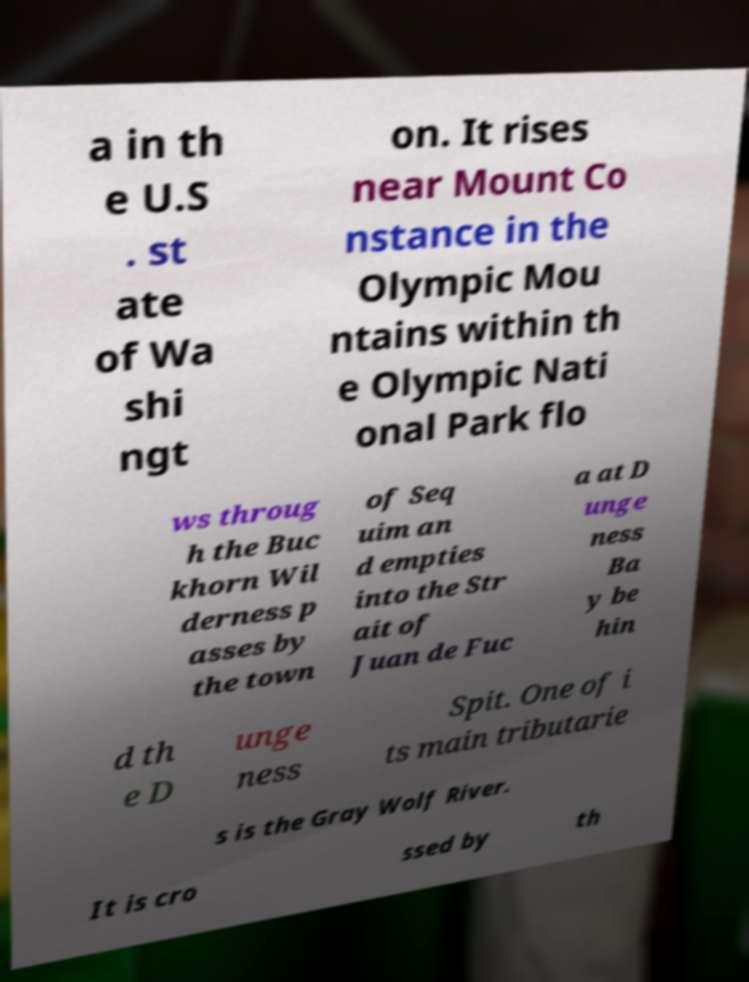Please identify and transcribe the text found in this image. a in th e U.S . st ate of Wa shi ngt on. It rises near Mount Co nstance in the Olympic Mou ntains within th e Olympic Nati onal Park flo ws throug h the Buc khorn Wil derness p asses by the town of Seq uim an d empties into the Str ait of Juan de Fuc a at D unge ness Ba y be hin d th e D unge ness Spit. One of i ts main tributarie s is the Gray Wolf River. It is cro ssed by th 